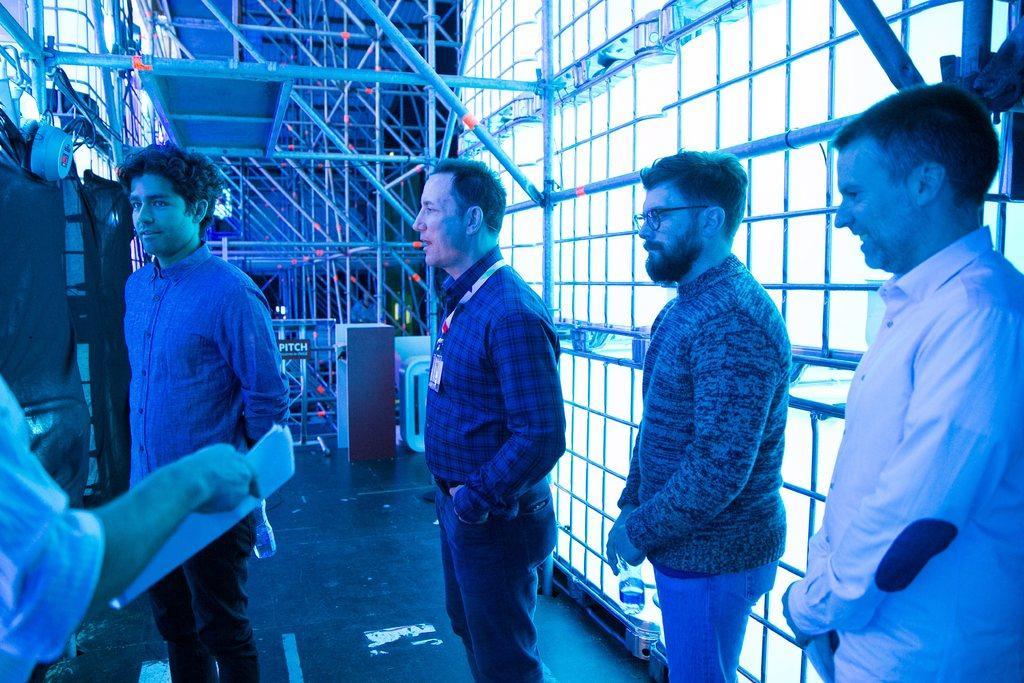Describe this image in one or two sentences. This picture is clicked inside. In the center we can see the group of people standing on the ground. On the left there is a person holding some objects and standing on the ground. In the background we can see the metal rods and many other objects placed on the ground. 